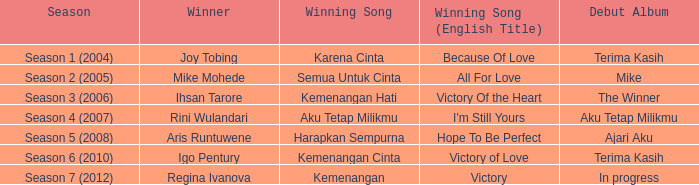Who triumphed with the song kemenangan cinta? Igo Pentury. 